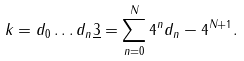<formula> <loc_0><loc_0><loc_500><loc_500>k = d _ { 0 } \dots d _ { n } \underline { 3 } = \sum _ { n = 0 } ^ { N } 4 ^ { n } d _ { n } - 4 ^ { N + 1 } .</formula> 